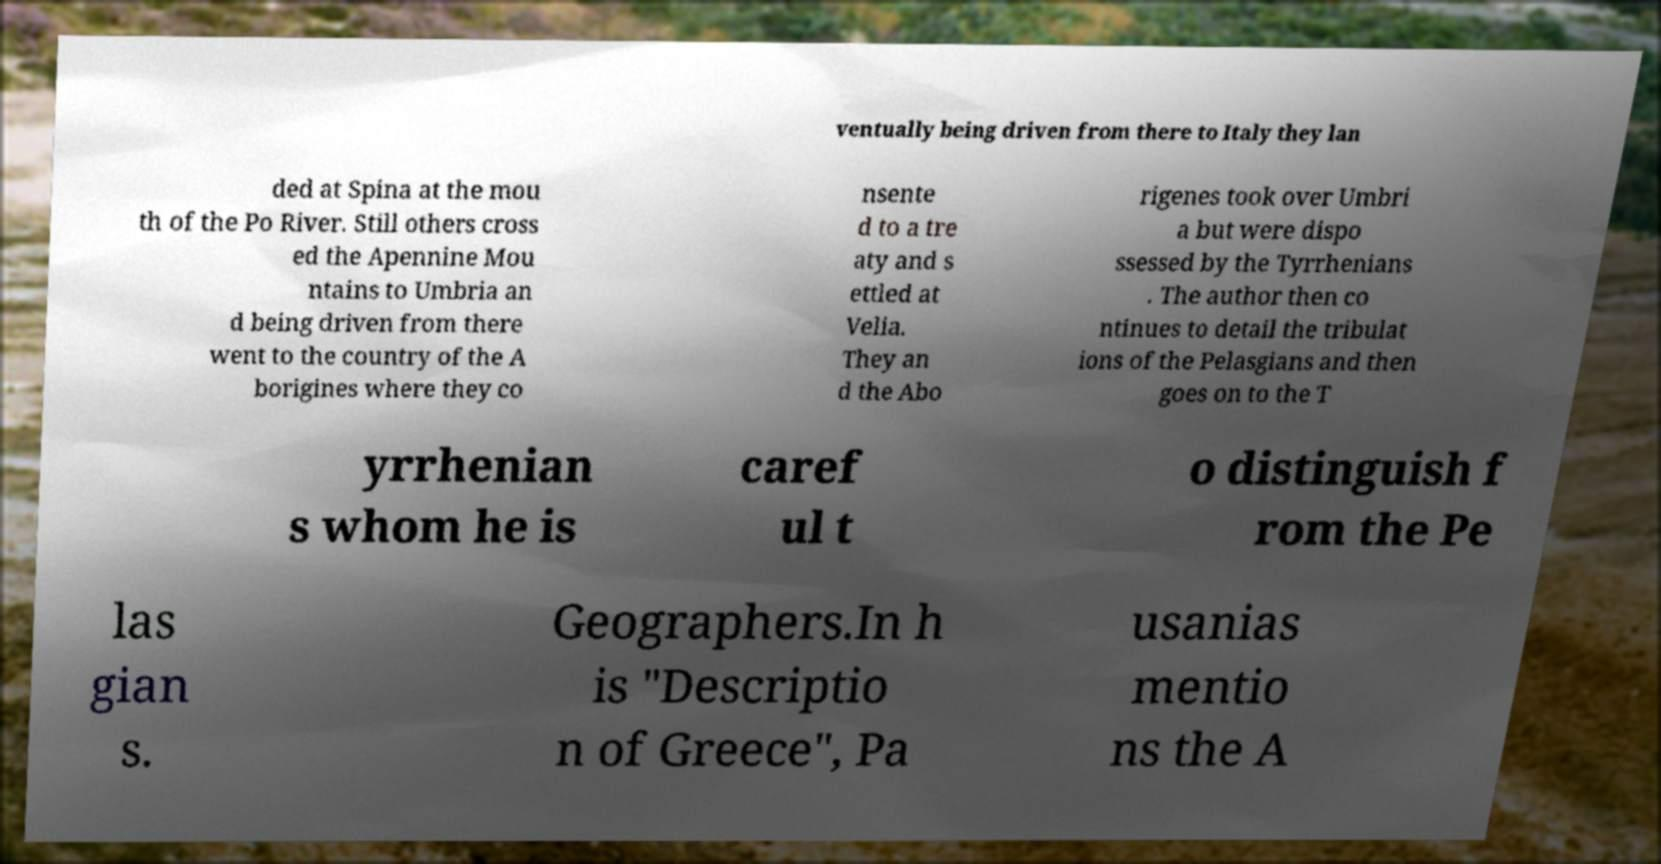Could you assist in decoding the text presented in this image and type it out clearly? ventually being driven from there to Italy they lan ded at Spina at the mou th of the Po River. Still others cross ed the Apennine Mou ntains to Umbria an d being driven from there went to the country of the A borigines where they co nsente d to a tre aty and s ettled at Velia. They an d the Abo rigenes took over Umbri a but were dispo ssessed by the Tyrrhenians . The author then co ntinues to detail the tribulat ions of the Pelasgians and then goes on to the T yrrhenian s whom he is caref ul t o distinguish f rom the Pe las gian s. Geographers.In h is "Descriptio n of Greece", Pa usanias mentio ns the A 